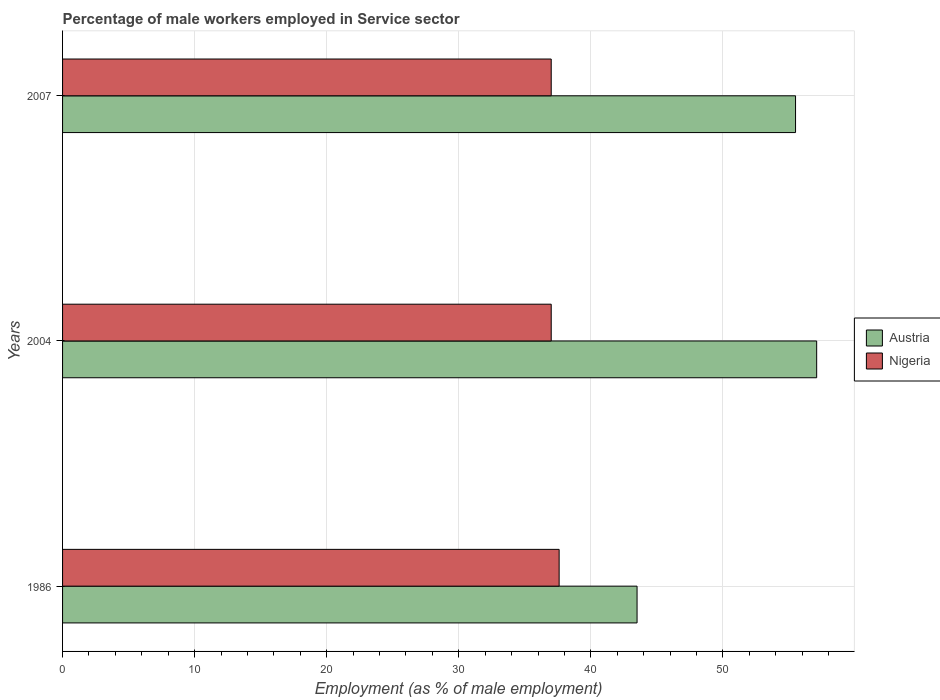How many different coloured bars are there?
Give a very brief answer. 2. Are the number of bars per tick equal to the number of legend labels?
Offer a terse response. Yes. How many bars are there on the 3rd tick from the top?
Your response must be concise. 2. How many bars are there on the 1st tick from the bottom?
Give a very brief answer. 2. What is the label of the 3rd group of bars from the top?
Your answer should be very brief. 1986. In how many cases, is the number of bars for a given year not equal to the number of legend labels?
Make the answer very short. 0. Across all years, what is the maximum percentage of male workers employed in Service sector in Austria?
Your answer should be very brief. 57.1. In which year was the percentage of male workers employed in Service sector in Nigeria maximum?
Give a very brief answer. 1986. What is the total percentage of male workers employed in Service sector in Austria in the graph?
Your response must be concise. 156.1. What is the difference between the percentage of male workers employed in Service sector in Nigeria in 1986 and that in 2007?
Provide a short and direct response. 0.6. What is the difference between the percentage of male workers employed in Service sector in Nigeria in 2004 and the percentage of male workers employed in Service sector in Austria in 2007?
Ensure brevity in your answer.  -18.5. What is the average percentage of male workers employed in Service sector in Nigeria per year?
Provide a succinct answer. 37.2. In the year 1986, what is the difference between the percentage of male workers employed in Service sector in Austria and percentage of male workers employed in Service sector in Nigeria?
Your response must be concise. 5.9. What is the ratio of the percentage of male workers employed in Service sector in Austria in 1986 to that in 2007?
Your response must be concise. 0.78. What is the difference between the highest and the second highest percentage of male workers employed in Service sector in Nigeria?
Keep it short and to the point. 0.6. What is the difference between the highest and the lowest percentage of male workers employed in Service sector in Austria?
Keep it short and to the point. 13.6. In how many years, is the percentage of male workers employed in Service sector in Nigeria greater than the average percentage of male workers employed in Service sector in Nigeria taken over all years?
Provide a succinct answer. 1. What does the 2nd bar from the top in 1986 represents?
Provide a short and direct response. Austria. What does the 2nd bar from the bottom in 2004 represents?
Your response must be concise. Nigeria. How many years are there in the graph?
Make the answer very short. 3. Are the values on the major ticks of X-axis written in scientific E-notation?
Offer a terse response. No. Does the graph contain any zero values?
Provide a short and direct response. No. How many legend labels are there?
Offer a very short reply. 2. What is the title of the graph?
Make the answer very short. Percentage of male workers employed in Service sector. What is the label or title of the X-axis?
Your answer should be compact. Employment (as % of male employment). What is the label or title of the Y-axis?
Give a very brief answer. Years. What is the Employment (as % of male employment) in Austria in 1986?
Provide a short and direct response. 43.5. What is the Employment (as % of male employment) of Nigeria in 1986?
Your response must be concise. 37.6. What is the Employment (as % of male employment) in Austria in 2004?
Make the answer very short. 57.1. What is the Employment (as % of male employment) of Nigeria in 2004?
Your response must be concise. 37. What is the Employment (as % of male employment) in Austria in 2007?
Ensure brevity in your answer.  55.5. What is the Employment (as % of male employment) in Nigeria in 2007?
Give a very brief answer. 37. Across all years, what is the maximum Employment (as % of male employment) in Austria?
Your response must be concise. 57.1. Across all years, what is the maximum Employment (as % of male employment) of Nigeria?
Provide a succinct answer. 37.6. Across all years, what is the minimum Employment (as % of male employment) in Austria?
Give a very brief answer. 43.5. What is the total Employment (as % of male employment) of Austria in the graph?
Provide a short and direct response. 156.1. What is the total Employment (as % of male employment) in Nigeria in the graph?
Ensure brevity in your answer.  111.6. What is the difference between the Employment (as % of male employment) in Nigeria in 1986 and that in 2004?
Make the answer very short. 0.6. What is the difference between the Employment (as % of male employment) of Nigeria in 2004 and that in 2007?
Ensure brevity in your answer.  0. What is the difference between the Employment (as % of male employment) in Austria in 1986 and the Employment (as % of male employment) in Nigeria in 2004?
Keep it short and to the point. 6.5. What is the difference between the Employment (as % of male employment) of Austria in 1986 and the Employment (as % of male employment) of Nigeria in 2007?
Keep it short and to the point. 6.5. What is the difference between the Employment (as % of male employment) of Austria in 2004 and the Employment (as % of male employment) of Nigeria in 2007?
Make the answer very short. 20.1. What is the average Employment (as % of male employment) of Austria per year?
Your answer should be compact. 52.03. What is the average Employment (as % of male employment) of Nigeria per year?
Provide a succinct answer. 37.2. In the year 2004, what is the difference between the Employment (as % of male employment) in Austria and Employment (as % of male employment) in Nigeria?
Offer a terse response. 20.1. In the year 2007, what is the difference between the Employment (as % of male employment) in Austria and Employment (as % of male employment) in Nigeria?
Offer a terse response. 18.5. What is the ratio of the Employment (as % of male employment) in Austria in 1986 to that in 2004?
Ensure brevity in your answer.  0.76. What is the ratio of the Employment (as % of male employment) in Nigeria in 1986 to that in 2004?
Offer a terse response. 1.02. What is the ratio of the Employment (as % of male employment) in Austria in 1986 to that in 2007?
Offer a very short reply. 0.78. What is the ratio of the Employment (as % of male employment) of Nigeria in 1986 to that in 2007?
Offer a terse response. 1.02. What is the ratio of the Employment (as % of male employment) in Austria in 2004 to that in 2007?
Your answer should be compact. 1.03. What is the difference between the highest and the second highest Employment (as % of male employment) of Austria?
Make the answer very short. 1.6. 